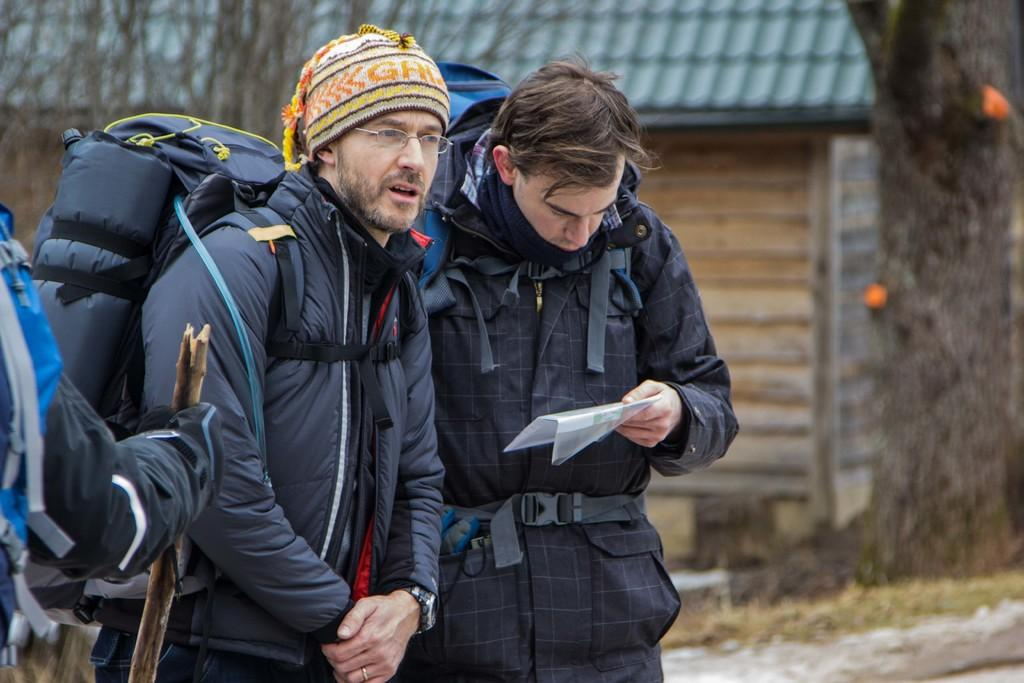How many people are in the image? There are 2 people standing in the image. What is one of the people doing? One person is reading. What can be seen behind the person on the right? There is a room visible behind the person at the right. What is visible in the background of the image? Trees are present in the background of the image. Is there a slave wearing a crown in the image? No, there is no slave or crown present in the image. What type of fog can be seen in the background of the image? There is no fog visible in the background of the image; it features trees instead. 